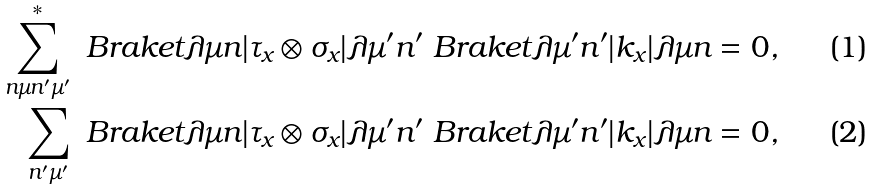<formula> <loc_0><loc_0><loc_500><loc_500>\sum _ { n \mu n ^ { \prime } \mu ^ { \prime } } ^ { * } \ B r a k e t { \lambda \mu n | \tau _ { x } \otimes \sigma _ { x } | \lambda \mu ^ { \prime } n ^ { \prime } } \ B r a k e t { \lambda \mu ^ { \prime } n ^ { \prime } | k _ { x } | \lambda \mu n } & = 0 , \\ \sum _ { n ^ { \prime } \mu ^ { \prime } } \ B r a k e t { \lambda \mu n | \tau _ { x } \otimes \sigma _ { x } | \lambda \mu ^ { \prime } n ^ { \prime } } \ B r a k e t { \lambda \mu ^ { \prime } n ^ { \prime } | k _ { x } | \lambda \mu n } & = 0 ,</formula> 